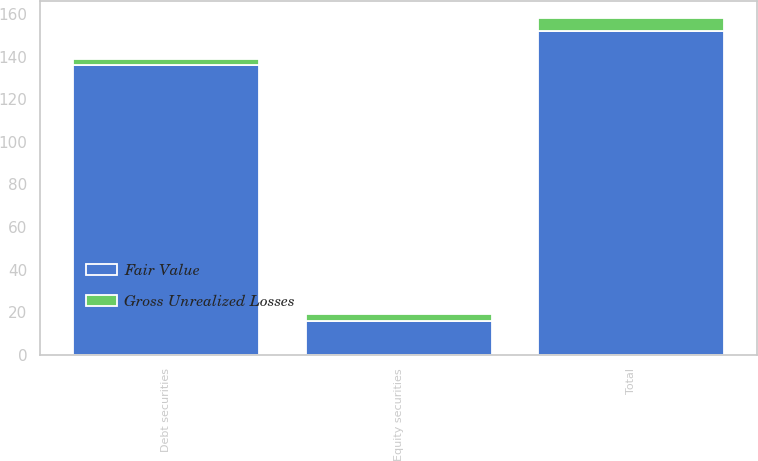Convert chart to OTSL. <chart><loc_0><loc_0><loc_500><loc_500><stacked_bar_chart><ecel><fcel>Debt securities<fcel>Equity securities<fcel>Total<nl><fcel>Fair Value<fcel>136<fcel>16<fcel>152<nl><fcel>Gross Unrealized Losses<fcel>3<fcel>3<fcel>6<nl></chart> 